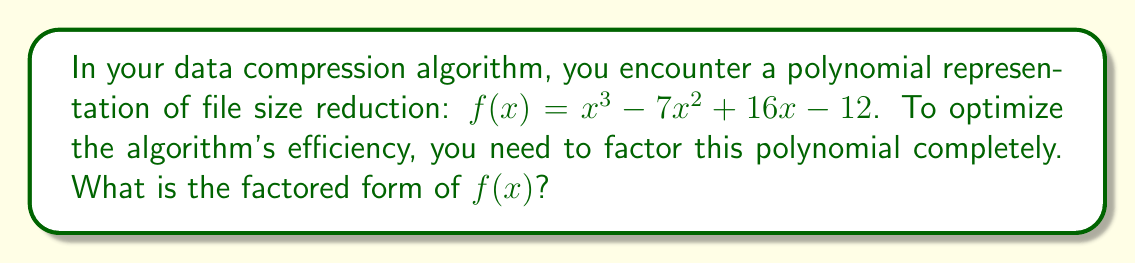Can you solve this math problem? Let's approach this step-by-step:

1) First, we should check if there are any rational roots. We can use the rational root theorem to list possible roots:
   Factors of the constant term (12): $\pm 1, \pm 2, \pm 3, \pm 4, \pm 6, \pm 12$

2) Testing these values, we find that $x = 1$ is a root of the polynomial.

3) We can use polynomial long division to divide $f(x)$ by $(x - 1)$:

   $$
   \begin{array}{r}
   x^2 - 6x + 10 \\
   x - 1 \enclose{longdiv}{x^3 - 7x^2 + 16x - 12} \\
   \underline{x^3 - x^2} \\
   -6x^2 + 16x \\
   \underline{-6x^2 + 6x} \\
   10x - 12 \\
   \underline{10x - 10} \\
   -2
   \end{array}
   $$

4) So, $f(x) = (x - 1)(x^2 - 6x + 10) - 2$

5) For the quadratic factor $x^2 - 6x + 10$, we can use the quadratic formula or factoring by grouping.
   The quadratic formula gives us:
   $$x = \frac{6 \pm \sqrt{36 - 40}}{2} = \frac{6 \pm \sqrt{-4}}{2} = 3 \pm i$$

6) Therefore, $x^2 - 6x + 10 = (x - (3+i))(x - (3-i))$

7) Putting it all together:
   $f(x) = (x - 1)(x - (3+i))(x - (3-i))$

This factorization reveals the roots of the polynomial, which can be used to optimize the compression algorithm at specific input values.
Answer: $f(x) = (x - 1)(x - (3+i))(x - (3-i))$ 